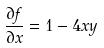<formula> <loc_0><loc_0><loc_500><loc_500>\frac { \partial f } { \partial x } = 1 - 4 x y</formula> 